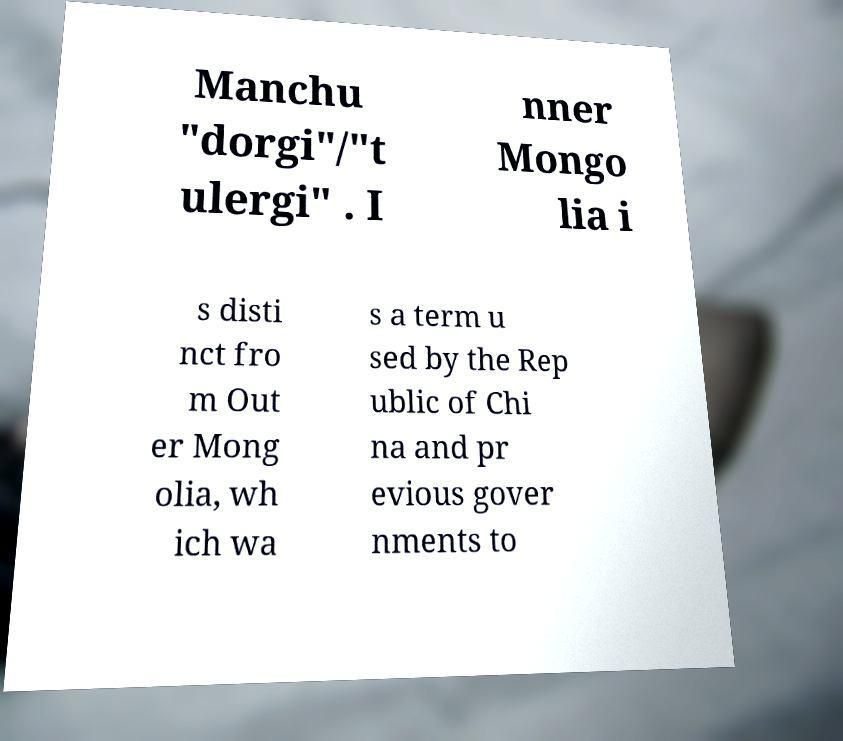Can you accurately transcribe the text from the provided image for me? Manchu "dorgi"/"t ulergi" . I nner Mongo lia i s disti nct fro m Out er Mong olia, wh ich wa s a term u sed by the Rep ublic of Chi na and pr evious gover nments to 